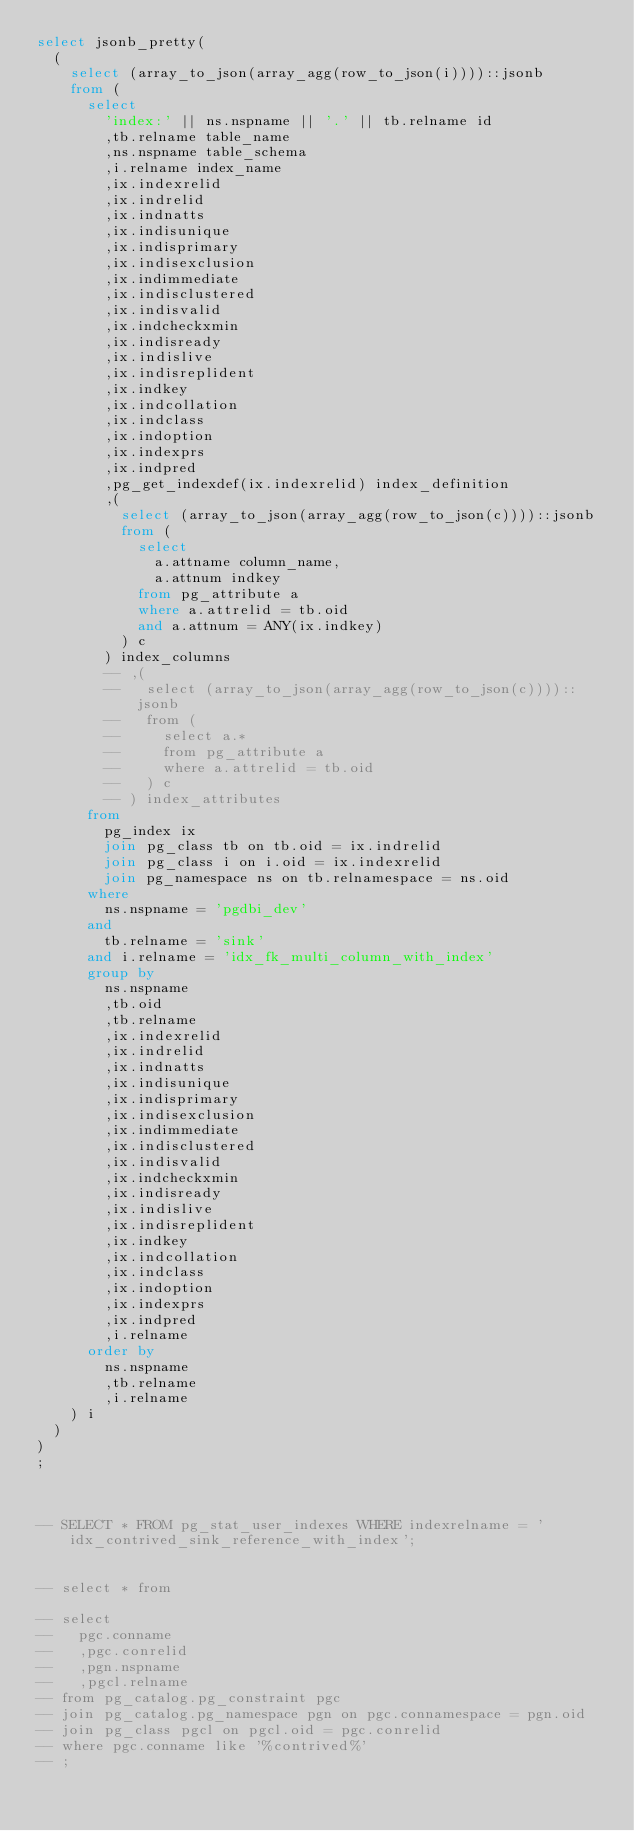<code> <loc_0><loc_0><loc_500><loc_500><_SQL_>select jsonb_pretty(
  (
    select (array_to_json(array_agg(row_to_json(i))))::jsonb
    from (
      select 
        'index:' || ns.nspname || '.' || tb.relname id
        ,tb.relname table_name
        ,ns.nspname table_schema
        ,i.relname index_name
        ,ix.indexrelid
        ,ix.indrelid
        ,ix.indnatts
        ,ix.indisunique
        ,ix.indisprimary
        ,ix.indisexclusion
        ,ix.indimmediate
        ,ix.indisclustered
        ,ix.indisvalid
        ,ix.indcheckxmin
        ,ix.indisready
        ,ix.indislive
        ,ix.indisreplident
        ,ix.indkey
        ,ix.indcollation
        ,ix.indclass
        ,ix.indoption
        ,ix.indexprs
        ,ix.indpred
        ,pg_get_indexdef(ix.indexrelid) index_definition
        ,(
          select (array_to_json(array_agg(row_to_json(c))))::jsonb
          from (
            select 
              a.attname column_name,
              a.attnum indkey
            from pg_attribute a
            where a.attrelid = tb.oid 
            and a.attnum = ANY(ix.indkey)
          ) c
        ) index_columns
        -- ,(
        --   select (array_to_json(array_agg(row_to_json(c))))::jsonb
        --   from (
        --     select a.*
        --     from pg_attribute a
        --     where a.attrelid = tb.oid
        --   ) c
        -- ) index_attributes
      from 
        pg_index ix
        join pg_class tb on tb.oid = ix.indrelid
        join pg_class i on i.oid = ix.indexrelid
        join pg_namespace ns on tb.relnamespace = ns.oid
      where
        ns.nspname = 'pgdbi_dev'
      and
        tb.relname = 'sink'
      and i.relname = 'idx_fk_multi_column_with_index'
      group by
        ns.nspname
        ,tb.oid
        ,tb.relname
        ,ix.indexrelid
        ,ix.indrelid
        ,ix.indnatts
        ,ix.indisunique
        ,ix.indisprimary
        ,ix.indisexclusion
        ,ix.indimmediate
        ,ix.indisclustered
        ,ix.indisvalid
        ,ix.indcheckxmin
        ,ix.indisready
        ,ix.indislive
        ,ix.indisreplident
        ,ix.indkey
        ,ix.indcollation
        ,ix.indclass
        ,ix.indoption
        ,ix.indexprs
        ,ix.indpred
        ,i.relname
      order by
        ns.nspname
        ,tb.relname
        ,i.relname
    ) i
  )
)
;



-- SELECT * FROM pg_stat_user_indexes WHERE indexrelname = 'idx_contrived_sink_reference_with_index';


-- select * from 

-- select
--   pgc.conname
--   ,pgc.conrelid
--   ,pgn.nspname
--   ,pgcl.relname
-- from pg_catalog.pg_constraint pgc
-- join pg_catalog.pg_namespace pgn on pgc.connamespace = pgn.oid
-- join pg_class pgcl on pgcl.oid = pgc.conrelid
-- where pgc.conname like '%contrived%'
-- ;</code> 